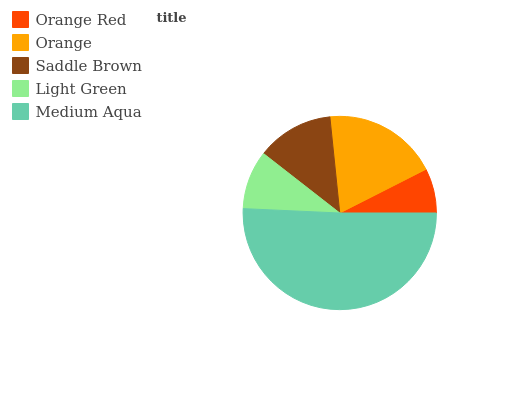Is Orange Red the minimum?
Answer yes or no. Yes. Is Medium Aqua the maximum?
Answer yes or no. Yes. Is Orange the minimum?
Answer yes or no. No. Is Orange the maximum?
Answer yes or no. No. Is Orange greater than Orange Red?
Answer yes or no. Yes. Is Orange Red less than Orange?
Answer yes or no. Yes. Is Orange Red greater than Orange?
Answer yes or no. No. Is Orange less than Orange Red?
Answer yes or no. No. Is Saddle Brown the high median?
Answer yes or no. Yes. Is Saddle Brown the low median?
Answer yes or no. Yes. Is Medium Aqua the high median?
Answer yes or no. No. Is Orange the low median?
Answer yes or no. No. 